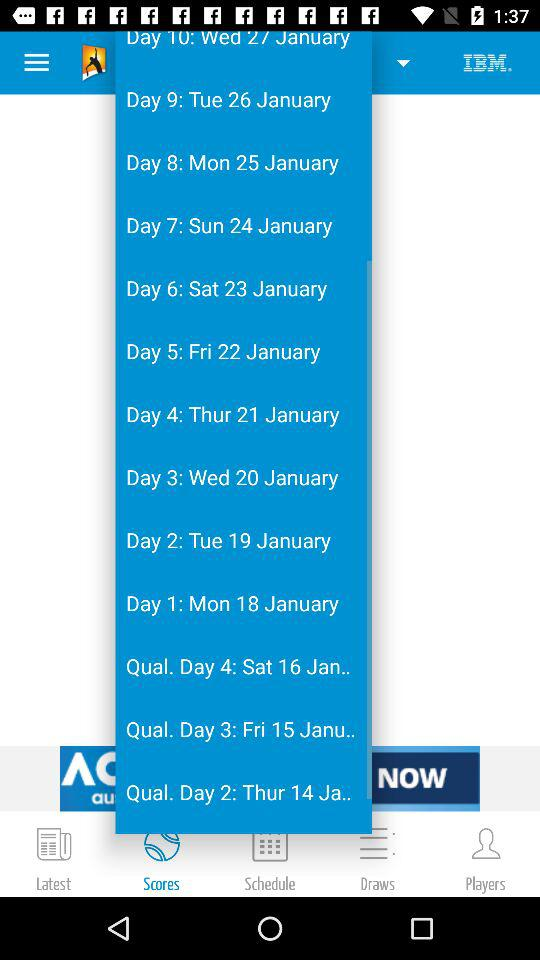Which tab is selected? The selected tab is "Scores". 